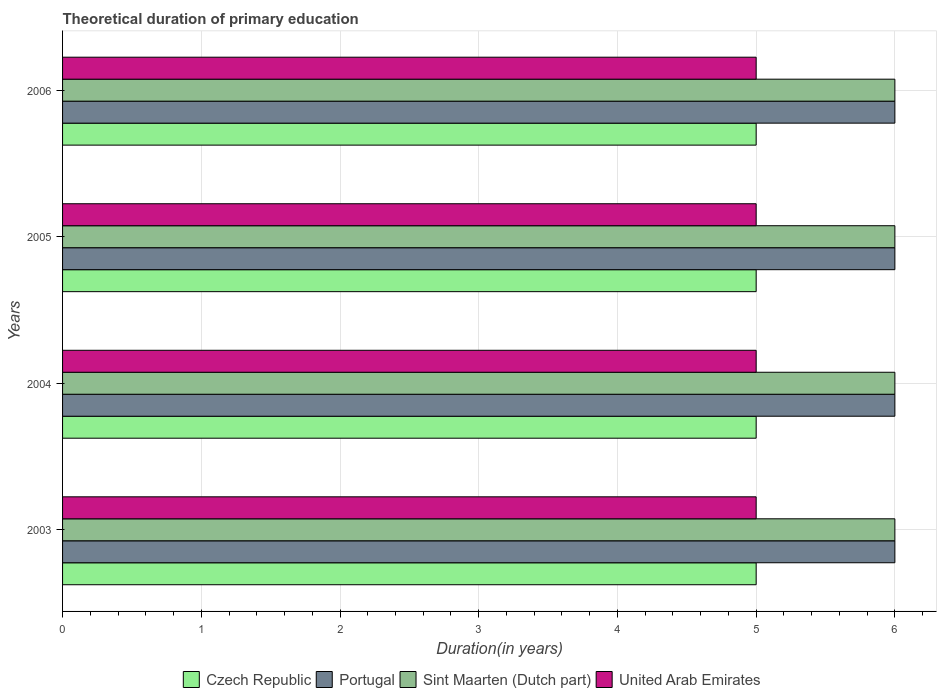How many different coloured bars are there?
Offer a very short reply. 4. How many groups of bars are there?
Make the answer very short. 4. How many bars are there on the 2nd tick from the top?
Your answer should be very brief. 4. What is the total theoretical duration of primary education in Portugal in 2004?
Keep it short and to the point. 6. Across all years, what is the maximum total theoretical duration of primary education in United Arab Emirates?
Provide a short and direct response. 5. Across all years, what is the minimum total theoretical duration of primary education in Czech Republic?
Your response must be concise. 5. In which year was the total theoretical duration of primary education in United Arab Emirates maximum?
Offer a very short reply. 2003. What is the difference between the total theoretical duration of primary education in Portugal in 2004 and that in 2006?
Your answer should be very brief. 0. What is the difference between the total theoretical duration of primary education in Czech Republic in 2004 and the total theoretical duration of primary education in Sint Maarten (Dutch part) in 2003?
Your response must be concise. -1. What is the average total theoretical duration of primary education in Czech Republic per year?
Your answer should be very brief. 5. In the year 2004, what is the difference between the total theoretical duration of primary education in Portugal and total theoretical duration of primary education in Czech Republic?
Your answer should be compact. 1. In how many years, is the total theoretical duration of primary education in United Arab Emirates greater than 3 years?
Offer a very short reply. 4. Is the difference between the total theoretical duration of primary education in Portugal in 2003 and 2004 greater than the difference between the total theoretical duration of primary education in Czech Republic in 2003 and 2004?
Provide a short and direct response. No. What is the difference between the highest and the second highest total theoretical duration of primary education in Portugal?
Provide a short and direct response. 0. What is the difference between the highest and the lowest total theoretical duration of primary education in Portugal?
Give a very brief answer. 0. In how many years, is the total theoretical duration of primary education in Czech Republic greater than the average total theoretical duration of primary education in Czech Republic taken over all years?
Provide a short and direct response. 0. What does the 4th bar from the top in 2003 represents?
Keep it short and to the point. Czech Republic. How many bars are there?
Your answer should be compact. 16. What is the difference between two consecutive major ticks on the X-axis?
Provide a succinct answer. 1. Are the values on the major ticks of X-axis written in scientific E-notation?
Give a very brief answer. No. Does the graph contain any zero values?
Provide a succinct answer. No. Does the graph contain grids?
Your answer should be compact. Yes. Where does the legend appear in the graph?
Make the answer very short. Bottom center. What is the title of the graph?
Ensure brevity in your answer.  Theoretical duration of primary education. What is the label or title of the X-axis?
Your answer should be very brief. Duration(in years). What is the label or title of the Y-axis?
Keep it short and to the point. Years. What is the Duration(in years) in Portugal in 2003?
Provide a short and direct response. 6. What is the Duration(in years) of Sint Maarten (Dutch part) in 2003?
Offer a very short reply. 6. What is the Duration(in years) in United Arab Emirates in 2003?
Ensure brevity in your answer.  5. What is the Duration(in years) in Czech Republic in 2004?
Keep it short and to the point. 5. What is the Duration(in years) of Portugal in 2004?
Offer a terse response. 6. What is the Duration(in years) of Sint Maarten (Dutch part) in 2004?
Provide a succinct answer. 6. What is the Duration(in years) of Czech Republic in 2005?
Offer a terse response. 5. What is the Duration(in years) of Sint Maarten (Dutch part) in 2005?
Your response must be concise. 6. What is the Duration(in years) in United Arab Emirates in 2005?
Your answer should be very brief. 5. Across all years, what is the maximum Duration(in years) in Portugal?
Your answer should be compact. 6. Across all years, what is the maximum Duration(in years) of Sint Maarten (Dutch part)?
Provide a short and direct response. 6. Across all years, what is the minimum Duration(in years) in Czech Republic?
Offer a terse response. 5. What is the total Duration(in years) in Sint Maarten (Dutch part) in the graph?
Offer a terse response. 24. What is the total Duration(in years) in United Arab Emirates in the graph?
Make the answer very short. 20. What is the difference between the Duration(in years) in Czech Republic in 2003 and that in 2004?
Provide a short and direct response. 0. What is the difference between the Duration(in years) in United Arab Emirates in 2003 and that in 2004?
Provide a succinct answer. 0. What is the difference between the Duration(in years) of Czech Republic in 2003 and that in 2005?
Provide a succinct answer. 0. What is the difference between the Duration(in years) of Portugal in 2003 and that in 2005?
Your answer should be very brief. 0. What is the difference between the Duration(in years) of Czech Republic in 2003 and that in 2006?
Provide a succinct answer. 0. What is the difference between the Duration(in years) of Sint Maarten (Dutch part) in 2003 and that in 2006?
Offer a very short reply. 0. What is the difference between the Duration(in years) of Czech Republic in 2004 and that in 2005?
Offer a terse response. 0. What is the difference between the Duration(in years) of United Arab Emirates in 2004 and that in 2005?
Make the answer very short. 0. What is the difference between the Duration(in years) in Czech Republic in 2004 and that in 2006?
Your answer should be very brief. 0. What is the difference between the Duration(in years) in Sint Maarten (Dutch part) in 2004 and that in 2006?
Offer a very short reply. 0. What is the difference between the Duration(in years) in United Arab Emirates in 2005 and that in 2006?
Provide a succinct answer. 0. What is the difference between the Duration(in years) of Czech Republic in 2003 and the Duration(in years) of Sint Maarten (Dutch part) in 2004?
Your answer should be compact. -1. What is the difference between the Duration(in years) of Czech Republic in 2003 and the Duration(in years) of United Arab Emirates in 2004?
Give a very brief answer. 0. What is the difference between the Duration(in years) in Portugal in 2003 and the Duration(in years) in Sint Maarten (Dutch part) in 2004?
Keep it short and to the point. 0. What is the difference between the Duration(in years) of Sint Maarten (Dutch part) in 2003 and the Duration(in years) of United Arab Emirates in 2004?
Offer a very short reply. 1. What is the difference between the Duration(in years) of Czech Republic in 2003 and the Duration(in years) of Portugal in 2005?
Ensure brevity in your answer.  -1. What is the difference between the Duration(in years) in Czech Republic in 2003 and the Duration(in years) in Sint Maarten (Dutch part) in 2005?
Provide a short and direct response. -1. What is the difference between the Duration(in years) in Czech Republic in 2003 and the Duration(in years) in United Arab Emirates in 2005?
Offer a terse response. 0. What is the difference between the Duration(in years) of Portugal in 2003 and the Duration(in years) of Sint Maarten (Dutch part) in 2005?
Ensure brevity in your answer.  0. What is the difference between the Duration(in years) in Portugal in 2003 and the Duration(in years) in United Arab Emirates in 2005?
Make the answer very short. 1. What is the difference between the Duration(in years) of Sint Maarten (Dutch part) in 2003 and the Duration(in years) of United Arab Emirates in 2005?
Give a very brief answer. 1. What is the difference between the Duration(in years) of Czech Republic in 2003 and the Duration(in years) of Portugal in 2006?
Provide a succinct answer. -1. What is the difference between the Duration(in years) in Portugal in 2003 and the Duration(in years) in United Arab Emirates in 2006?
Your response must be concise. 1. What is the difference between the Duration(in years) in Sint Maarten (Dutch part) in 2003 and the Duration(in years) in United Arab Emirates in 2006?
Give a very brief answer. 1. What is the difference between the Duration(in years) in Czech Republic in 2004 and the Duration(in years) in Sint Maarten (Dutch part) in 2005?
Offer a very short reply. -1. What is the difference between the Duration(in years) in Portugal in 2004 and the Duration(in years) in United Arab Emirates in 2005?
Make the answer very short. 1. What is the difference between the Duration(in years) in Sint Maarten (Dutch part) in 2004 and the Duration(in years) in United Arab Emirates in 2005?
Your response must be concise. 1. What is the difference between the Duration(in years) of Czech Republic in 2005 and the Duration(in years) of Portugal in 2006?
Provide a succinct answer. -1. What is the difference between the Duration(in years) of Czech Republic in 2005 and the Duration(in years) of Sint Maarten (Dutch part) in 2006?
Keep it short and to the point. -1. What is the difference between the Duration(in years) of Czech Republic in 2005 and the Duration(in years) of United Arab Emirates in 2006?
Keep it short and to the point. 0. What is the average Duration(in years) of Portugal per year?
Your answer should be very brief. 6. What is the average Duration(in years) of United Arab Emirates per year?
Offer a terse response. 5. In the year 2003, what is the difference between the Duration(in years) in Czech Republic and Duration(in years) in Portugal?
Your response must be concise. -1. In the year 2003, what is the difference between the Duration(in years) in Czech Republic and Duration(in years) in Sint Maarten (Dutch part)?
Provide a succinct answer. -1. In the year 2003, what is the difference between the Duration(in years) in Czech Republic and Duration(in years) in United Arab Emirates?
Make the answer very short. 0. In the year 2003, what is the difference between the Duration(in years) in Sint Maarten (Dutch part) and Duration(in years) in United Arab Emirates?
Ensure brevity in your answer.  1. In the year 2005, what is the difference between the Duration(in years) in Czech Republic and Duration(in years) in Portugal?
Ensure brevity in your answer.  -1. In the year 2005, what is the difference between the Duration(in years) of Czech Republic and Duration(in years) of Sint Maarten (Dutch part)?
Provide a short and direct response. -1. In the year 2005, what is the difference between the Duration(in years) of Czech Republic and Duration(in years) of United Arab Emirates?
Give a very brief answer. 0. In the year 2005, what is the difference between the Duration(in years) in Portugal and Duration(in years) in United Arab Emirates?
Provide a succinct answer. 1. In the year 2006, what is the difference between the Duration(in years) in Czech Republic and Duration(in years) in Portugal?
Offer a very short reply. -1. In the year 2006, what is the difference between the Duration(in years) in Czech Republic and Duration(in years) in United Arab Emirates?
Your answer should be compact. 0. What is the ratio of the Duration(in years) in Czech Republic in 2003 to that in 2004?
Provide a short and direct response. 1. What is the ratio of the Duration(in years) in Portugal in 2003 to that in 2004?
Your answer should be compact. 1. What is the ratio of the Duration(in years) in United Arab Emirates in 2003 to that in 2004?
Your response must be concise. 1. What is the ratio of the Duration(in years) of Sint Maarten (Dutch part) in 2003 to that in 2005?
Keep it short and to the point. 1. What is the ratio of the Duration(in years) of Czech Republic in 2003 to that in 2006?
Your answer should be very brief. 1. What is the ratio of the Duration(in years) in Portugal in 2003 to that in 2006?
Give a very brief answer. 1. What is the ratio of the Duration(in years) in United Arab Emirates in 2003 to that in 2006?
Make the answer very short. 1. What is the ratio of the Duration(in years) of Czech Republic in 2004 to that in 2005?
Your answer should be very brief. 1. What is the ratio of the Duration(in years) in Portugal in 2004 to that in 2005?
Your response must be concise. 1. What is the ratio of the Duration(in years) of Portugal in 2004 to that in 2006?
Your answer should be compact. 1. What is the ratio of the Duration(in years) in United Arab Emirates in 2004 to that in 2006?
Offer a very short reply. 1. What is the ratio of the Duration(in years) in Portugal in 2005 to that in 2006?
Make the answer very short. 1. What is the ratio of the Duration(in years) of Sint Maarten (Dutch part) in 2005 to that in 2006?
Ensure brevity in your answer.  1. What is the difference between the highest and the second highest Duration(in years) in Sint Maarten (Dutch part)?
Offer a terse response. 0. What is the difference between the highest and the lowest Duration(in years) of Czech Republic?
Ensure brevity in your answer.  0. What is the difference between the highest and the lowest Duration(in years) of Portugal?
Provide a succinct answer. 0. What is the difference between the highest and the lowest Duration(in years) in Sint Maarten (Dutch part)?
Offer a terse response. 0. What is the difference between the highest and the lowest Duration(in years) in United Arab Emirates?
Make the answer very short. 0. 